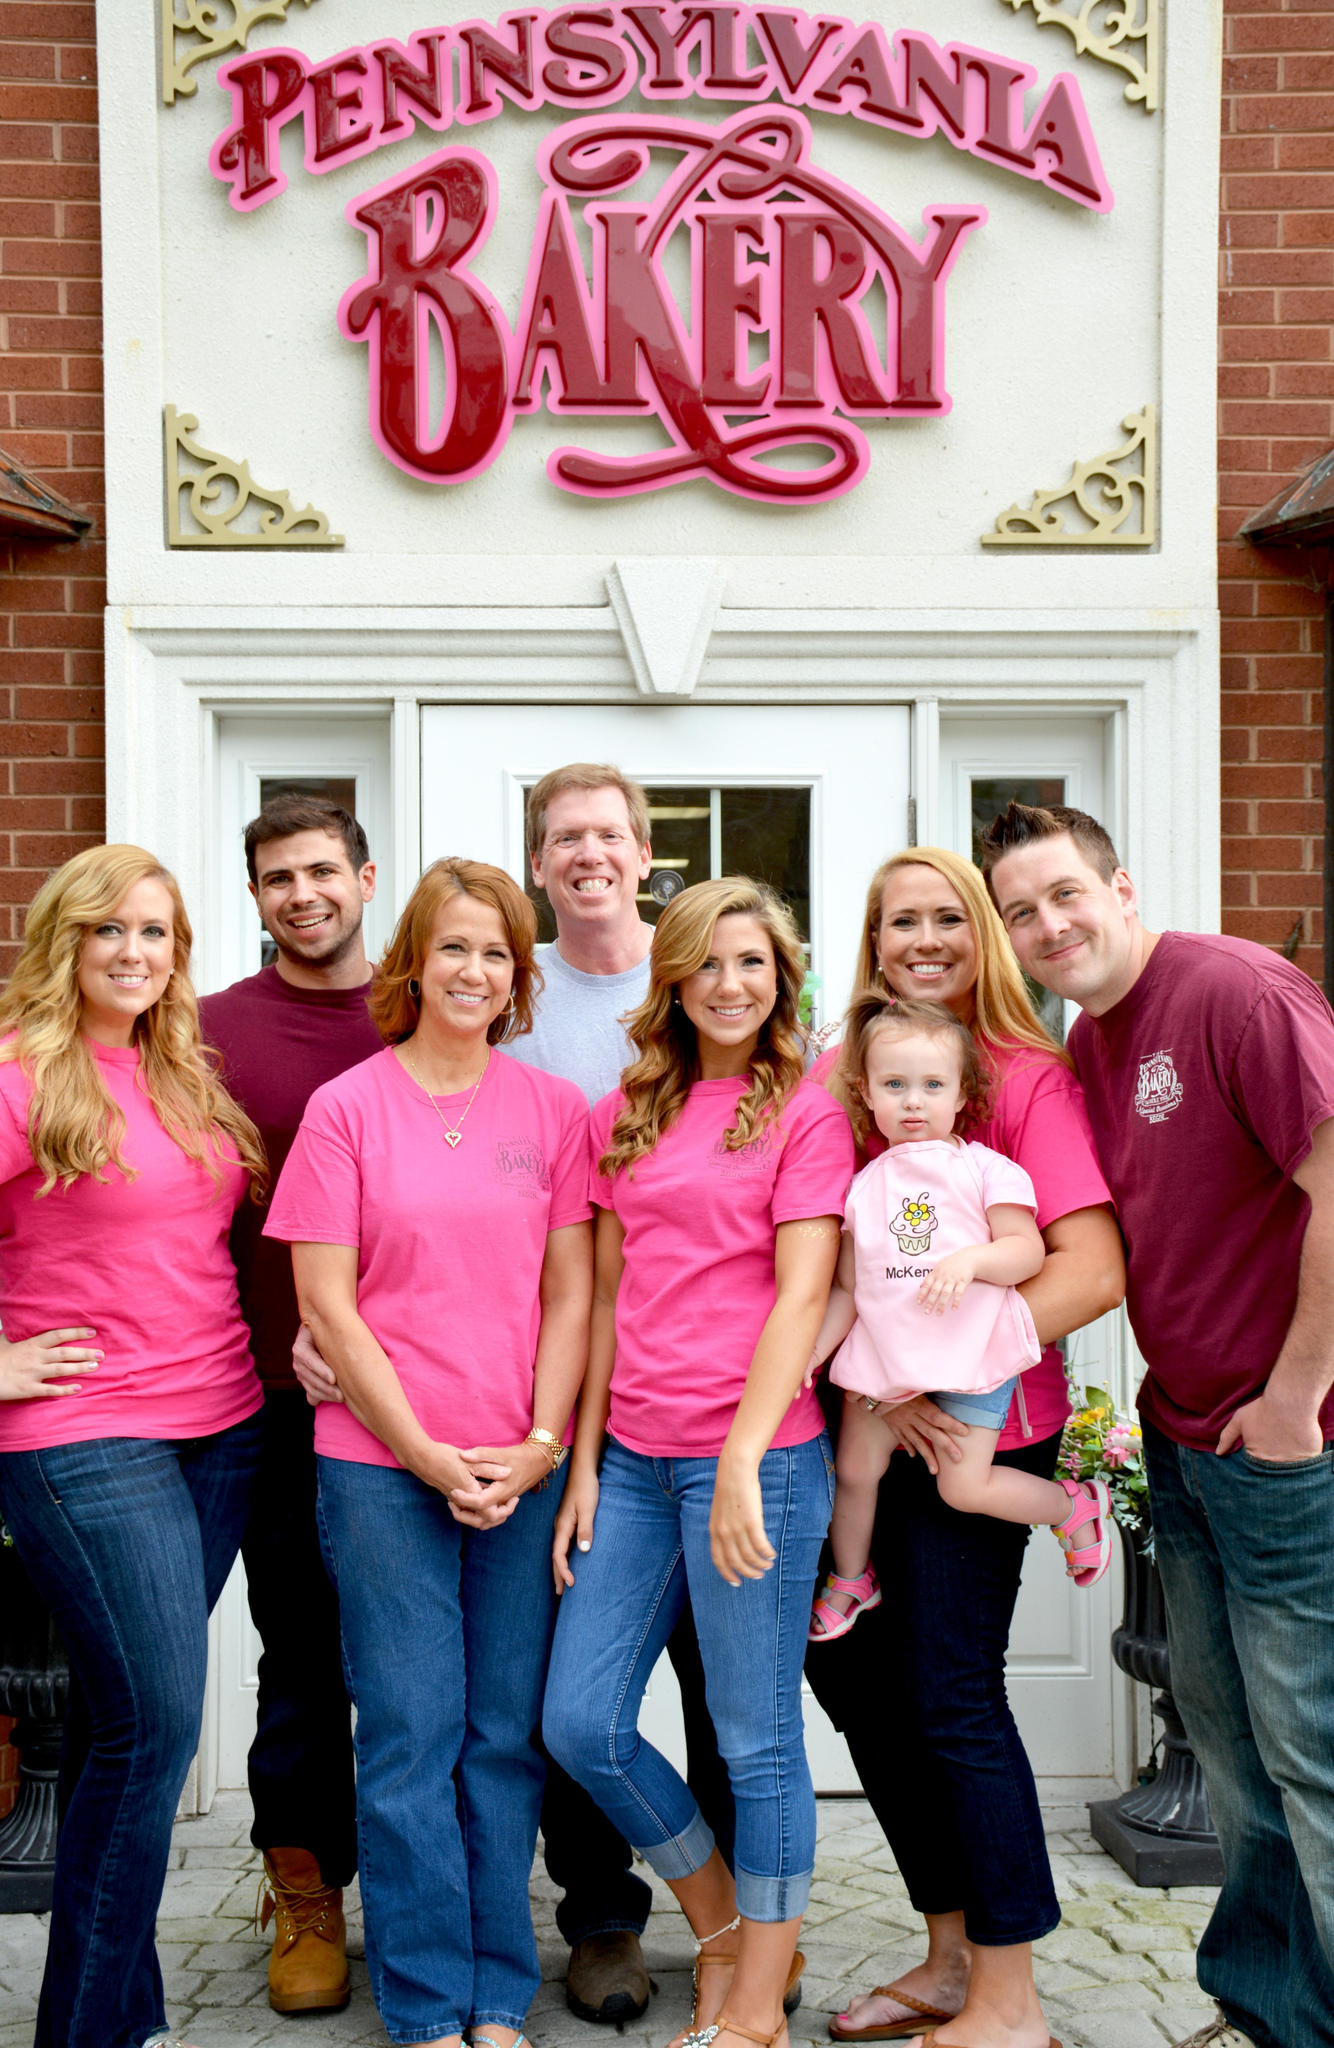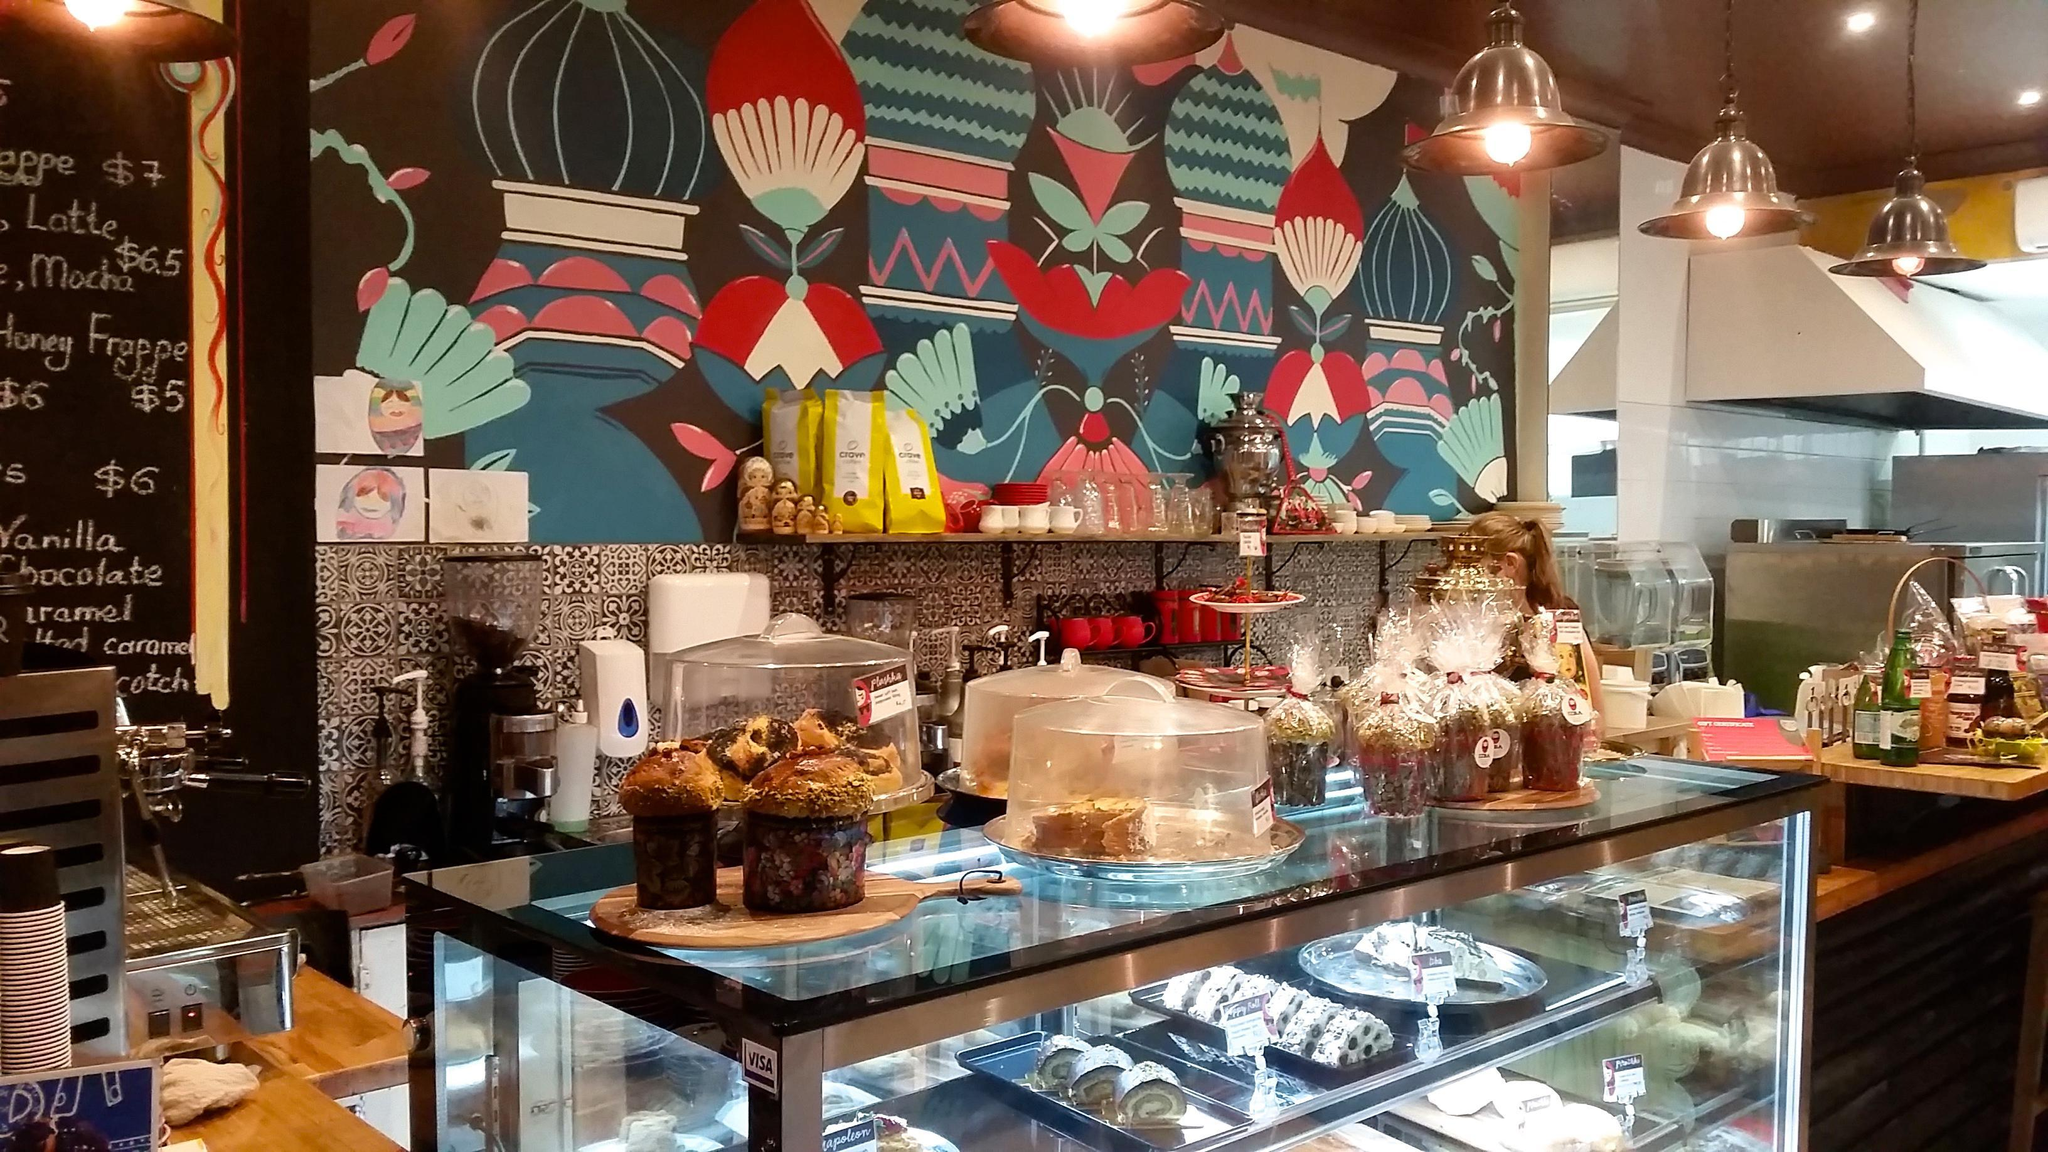The first image is the image on the left, the second image is the image on the right. Evaluate the accuracy of this statement regarding the images: "There are more women than there are men.". Is it true? Answer yes or no. Yes. The first image is the image on the left, the second image is the image on the right. For the images displayed, is the sentence "Has atleast one picture of a lone bearded man" factually correct? Answer yes or no. No. 